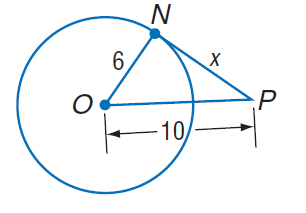Question: Find x. Assume that segments that appear to be tangent are tangent.
Choices:
A. 4
B. 6
C. 8
D. 19
Answer with the letter. Answer: C 